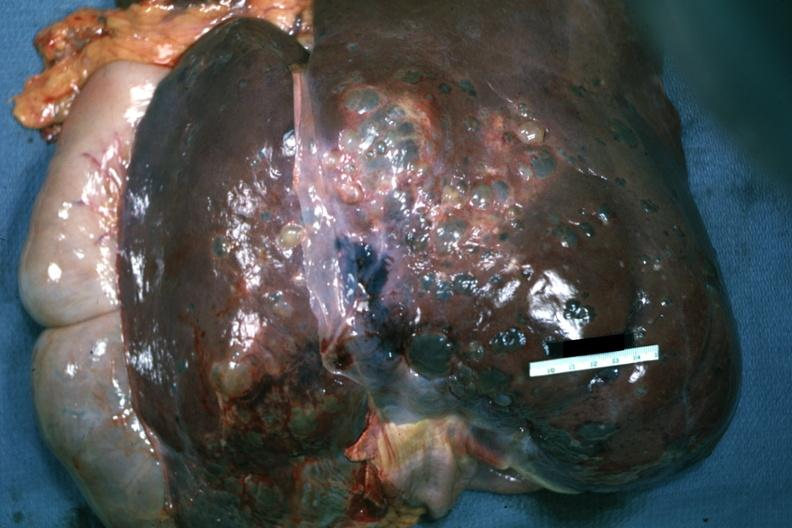s liver present?
Answer the question using a single word or phrase. Yes 